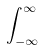Convert formula to latex. <formula><loc_0><loc_0><loc_500><loc_500>\int _ { - \infty } ^ { \infty }</formula> 